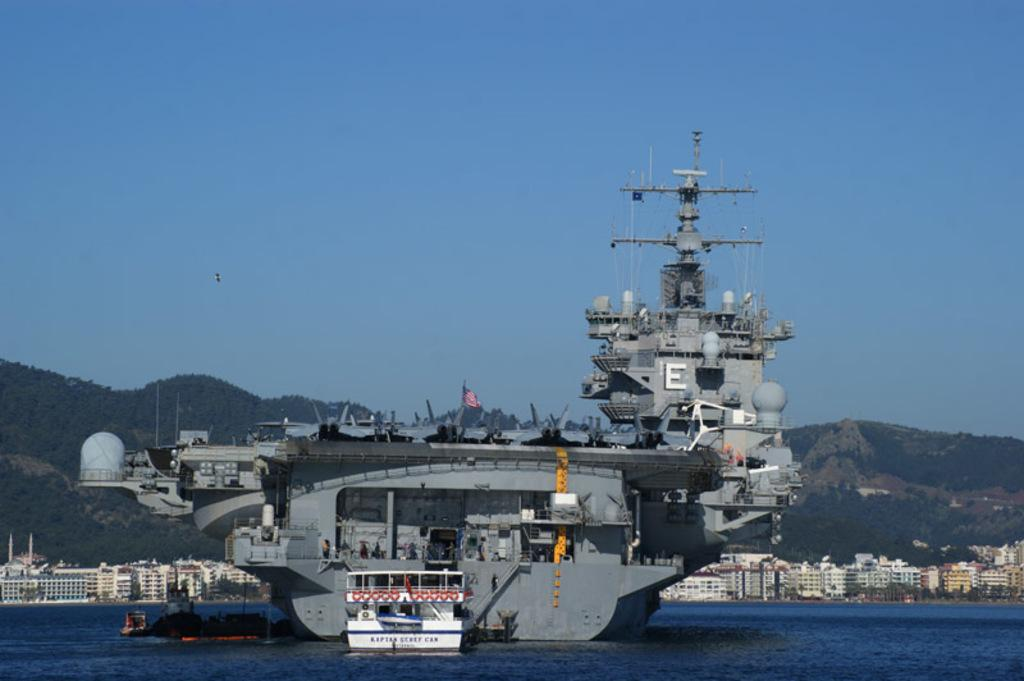What is the main subject of the image? The main subject of the image is a ship in the water. What can be seen on the ship? The ship has a flag. What is visible in the background of the image? There are buildings and trees in the background of the image. Who is the owner of the spade seen in the image? There is no spade present in the image. Can you tell me the name of the girl standing next to the ship? There is no girl present in the image; it only features a ship in the water. 